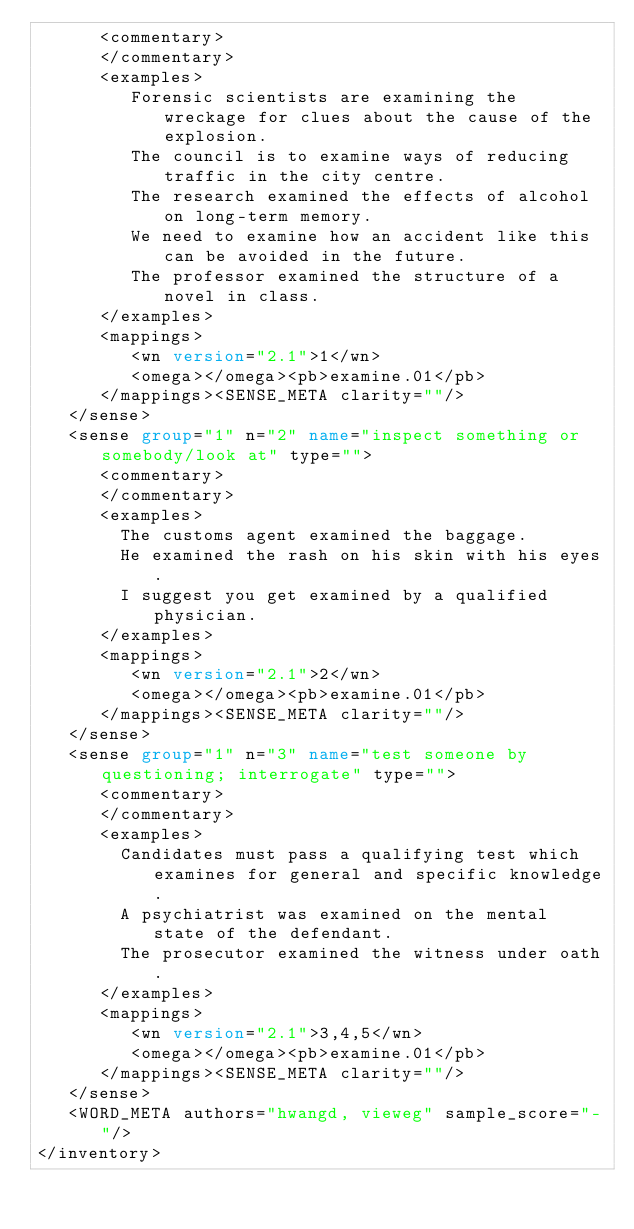<code> <loc_0><loc_0><loc_500><loc_500><_XML_>      <commentary>
      </commentary>
      <examples>
         Forensic scientists are examining the wreckage for clues about the cause of the explosion.
         The council is to examine ways of reducing traffic in the city centre.
         The research examined the effects of alcohol on long-term memory.
         We need to examine how an accident like this can be avoided in the future.
         The professor examined the structure of a novel in class.
      </examples>
      <mappings>
         <wn version="2.1">1</wn>
         <omega></omega><pb>examine.01</pb>
      </mappings><SENSE_META clarity=""/>
   </sense>
   <sense group="1" n="2" name="inspect something or somebody/look at" type="">
      <commentary>
      </commentary>
      <examples>
        The customs agent examined the baggage.
        He examined the rash on his skin with his eyes.
        I suggest you get examined by a qualified physician.
      </examples>
      <mappings>
         <wn version="2.1">2</wn>
         <omega></omega><pb>examine.01</pb>
      </mappings><SENSE_META clarity=""/>
   </sense>
   <sense group="1" n="3" name="test someone by questioning; interrogate" type="">
      <commentary>
      </commentary>
      <examples>
        Candidates must pass a qualifying test which examines for general and specific knowledge.
        A psychiatrist was examined on the mental state of the defendant.
        The prosecutor examined the witness under oath.
      </examples>
      <mappings>
         <wn version="2.1">3,4,5</wn>
         <omega></omega><pb>examine.01</pb>
      </mappings><SENSE_META clarity=""/>
   </sense>
   <WORD_META authors="hwangd, vieweg" sample_score="-"/>  
</inventory>

</code> 